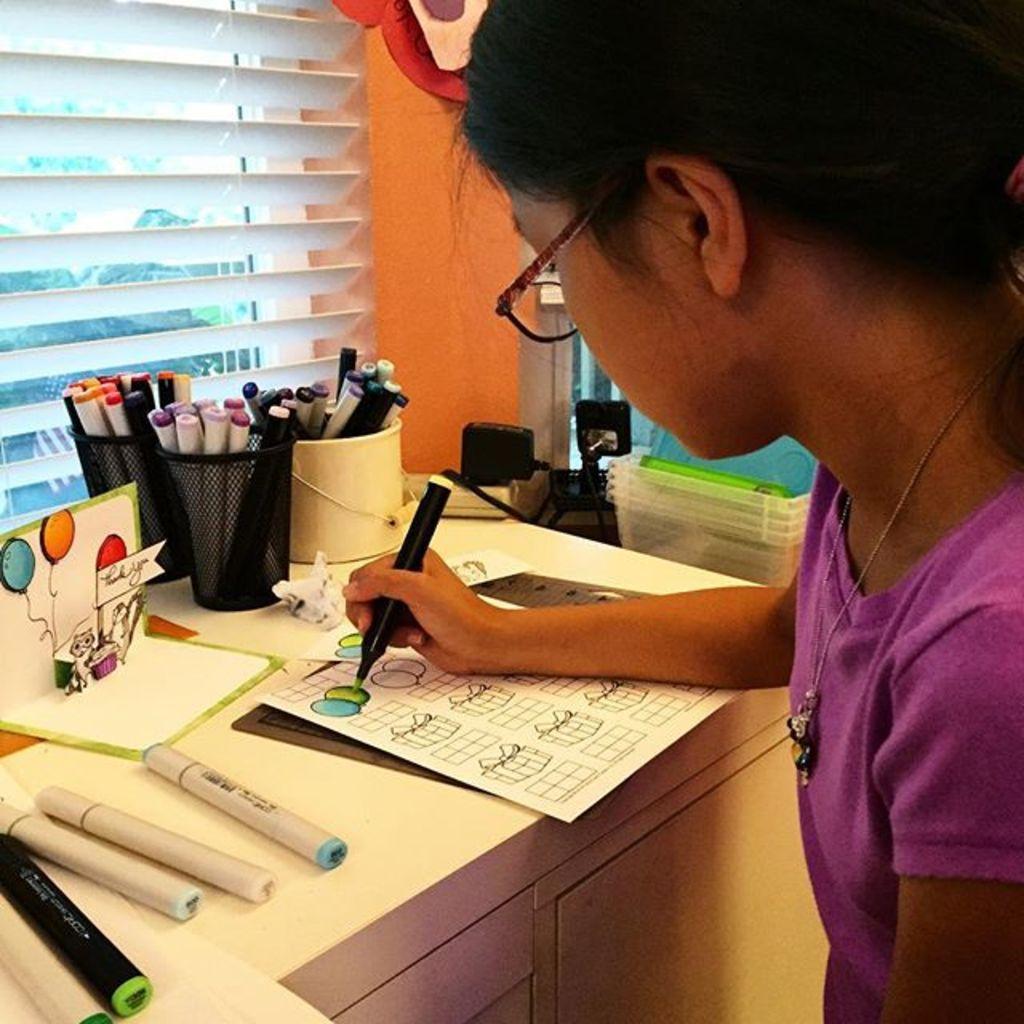Can you describe this image briefly? This image is taken indoors. In the background there is a window with a window blind and there is a wall. On the right side of the image there is a girl and she is holding a marker pen in her hand and writing on the paper. At the bottom of the image there is a table with a few marker pens, papers, pen holders and a few objects. There are a few boxes. 